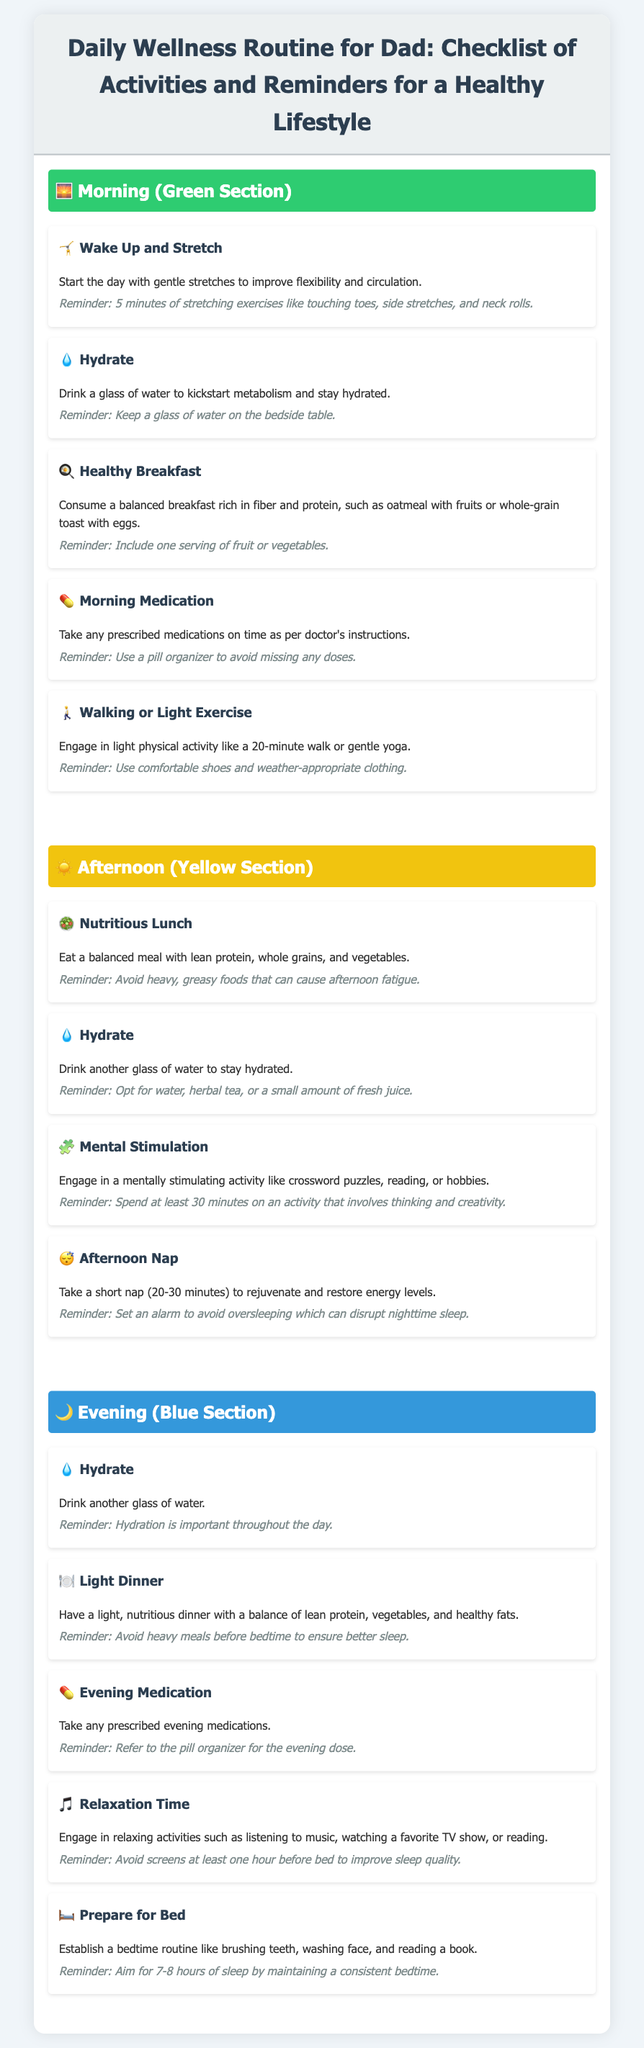What is the first activity in the morning routine? The first activity listed in the morning routine is "Wake Up and Stretch."
Answer: Wake Up and Stretch How many glasses of water should Dad drink throughout the day? The document mentions he should drink a glass of water in the morning, afternoon, and evening.
Answer: Three What type of breakfast is recommended? The healthy breakfast suggested is one that is "rich in fiber and protein."
Answer: Rich in fiber and protein What is the duration of the recommended afternoon nap? The document specifies that the afternoon nap should last for "20-30 minutes."
Answer: 20-30 minutes Which section is color-coded yellow? The afternoon activities are described in the yellow section.
Answer: Afternoon What should be included in Dad's evening routine before bedtime? The evening routine encourages establishing a "bedtime routine."
Answer: Bedtime routine What activity is suggested for mental stimulation in the afternoon? The document suggests engaging in "crossword puzzles, reading, or hobbies."
Answer: Crossword puzzles, reading, or hobbies What is advised to avoid before bedtime? The document advises to avoid "screens at least one hour before bed."
Answer: Screens What should Dad eat for lunch? He should have a "balanced meal with lean protein, whole grains, and vegetables."
Answer: Balanced meal with lean protein, whole grains, and vegetables 